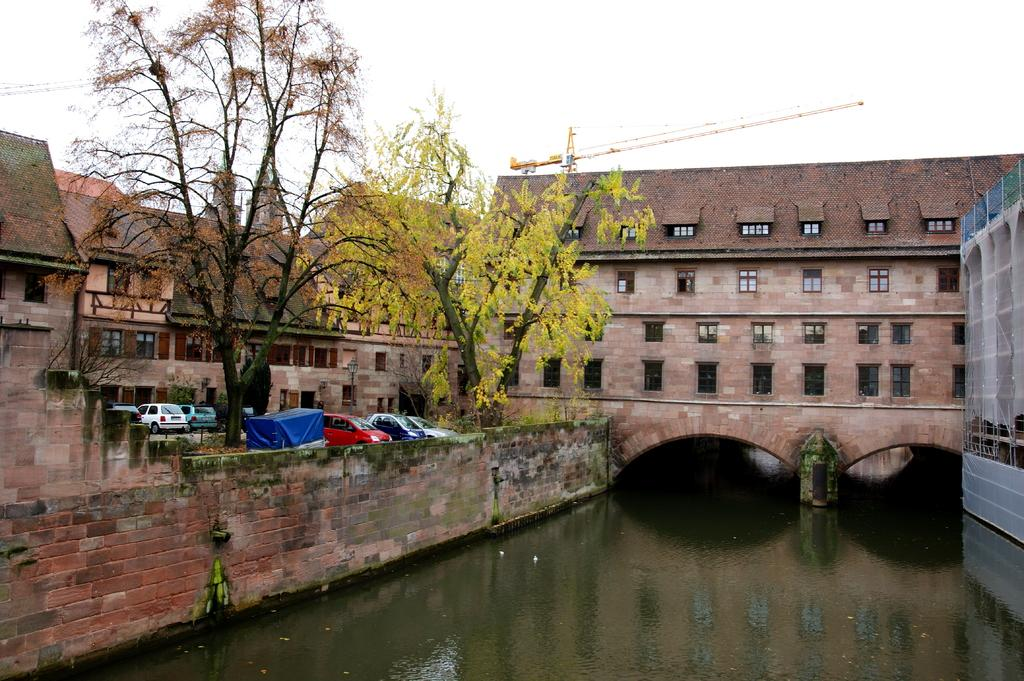What type of structures are visible in the image? There are buildings in the image. What can be seen in front of the buildings? There are cars parked in front of the buildings. What type of vegetation is beside the cars? There are trees beside the cars. What is located beside the building? There is a pool of water beside the building. What type of elbow can be seen in the image? There is no elbow present in the image. What type of trail is visible in the image? There is no trail visible in the image. 